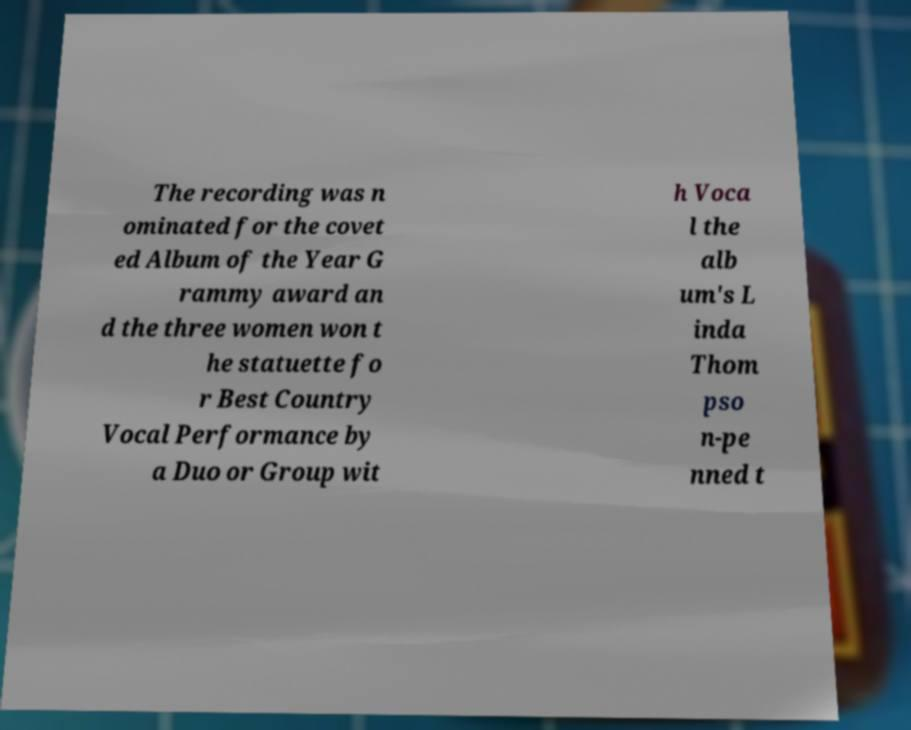Can you accurately transcribe the text from the provided image for me? The recording was n ominated for the covet ed Album of the Year G rammy award an d the three women won t he statuette fo r Best Country Vocal Performance by a Duo or Group wit h Voca l the alb um's L inda Thom pso n-pe nned t 